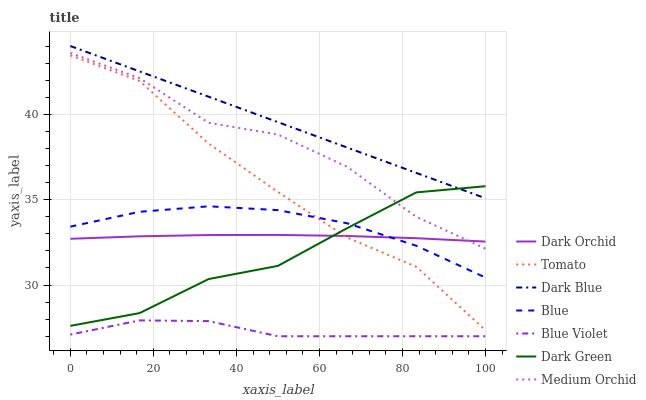Does Blue Violet have the minimum area under the curve?
Answer yes or no. Yes. Does Dark Blue have the maximum area under the curve?
Answer yes or no. Yes. Does Blue have the minimum area under the curve?
Answer yes or no. No. Does Blue have the maximum area under the curve?
Answer yes or no. No. Is Dark Blue the smoothest?
Answer yes or no. Yes. Is Medium Orchid the roughest?
Answer yes or no. Yes. Is Blue the smoothest?
Answer yes or no. No. Is Blue the roughest?
Answer yes or no. No. Does Blue Violet have the lowest value?
Answer yes or no. Yes. Does Blue have the lowest value?
Answer yes or no. No. Does Dark Blue have the highest value?
Answer yes or no. Yes. Does Blue have the highest value?
Answer yes or no. No. Is Blue Violet less than Dark Green?
Answer yes or no. Yes. Is Dark Blue greater than Blue Violet?
Answer yes or no. Yes. Does Dark Orchid intersect Medium Orchid?
Answer yes or no. Yes. Is Dark Orchid less than Medium Orchid?
Answer yes or no. No. Is Dark Orchid greater than Medium Orchid?
Answer yes or no. No. Does Blue Violet intersect Dark Green?
Answer yes or no. No. 